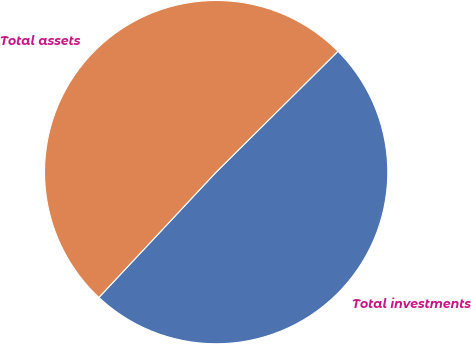<chart> <loc_0><loc_0><loc_500><loc_500><pie_chart><fcel>Total investments<fcel>Total assets<nl><fcel>49.41%<fcel>50.59%<nl></chart> 